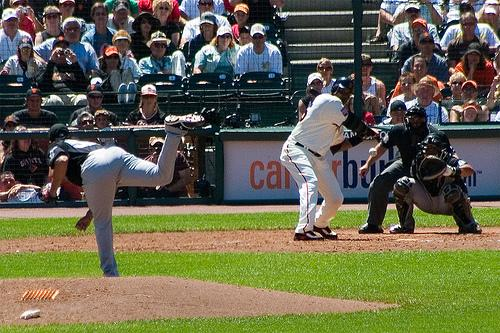What is the main sport being played in this image? Baseball. What color is the cap of the woman at (136, 77) coordinates in the image? The cap is white and red. What's happening on the pitchers mound in the image? The pitcher is throwing the baseball. What is the color of the hat worn by the man at coordinates (109, 28) in the image? The man is wearing a yellow hat. In this image, describe the colors worn by the main pitcher. The main pitcher is wearing a black jersey. What is something that can be observed about the grass in the image? The grass looks well cut and is aesthetically pleasing. Identify the color and type of advertisement at coordinates (228, 138) in the image. The advertisement is white, orange, and black in color. What is the most prominent activity happening among the spectators in the image? The fans are watching and enjoying the baseball game. What is the main action captured in this image? The image captures a baseball player throwing the ball while others in action playing the game. How would you describe the field in the image? The field is green, with dirt in some parts, and grass looking well maintained. Make sure to pay attention to the flying bird above the field, providing an amazing display of nature while the game is going on. No, it's not mentioned in the image. 